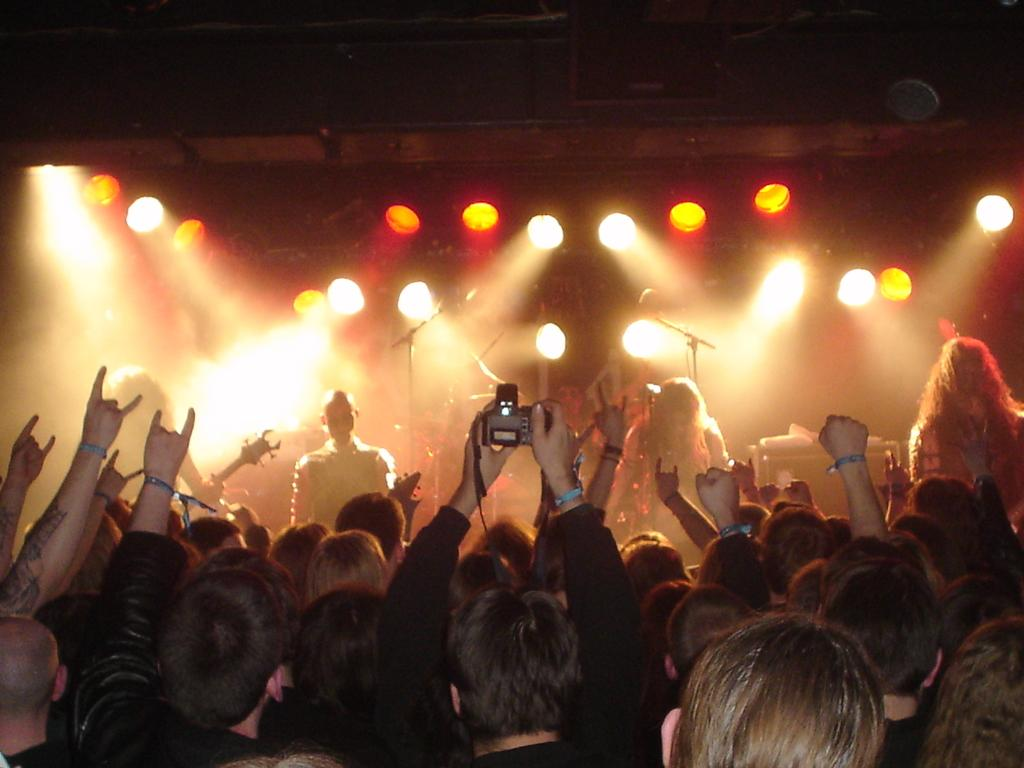How many people are in the image? There is a group of people in the image, but the exact number is not specified. What can be seen in the image besides the group of people? There is a camera, mic stands, lights, and some unspecified objects in the image. What is the lighting condition in the image? The background of the image is dark. What type of pan is being used to cook the cream in the image? There is no pan or cream present in the image. Can you see an airplane in the image? No, there is no airplane visible in the image. 